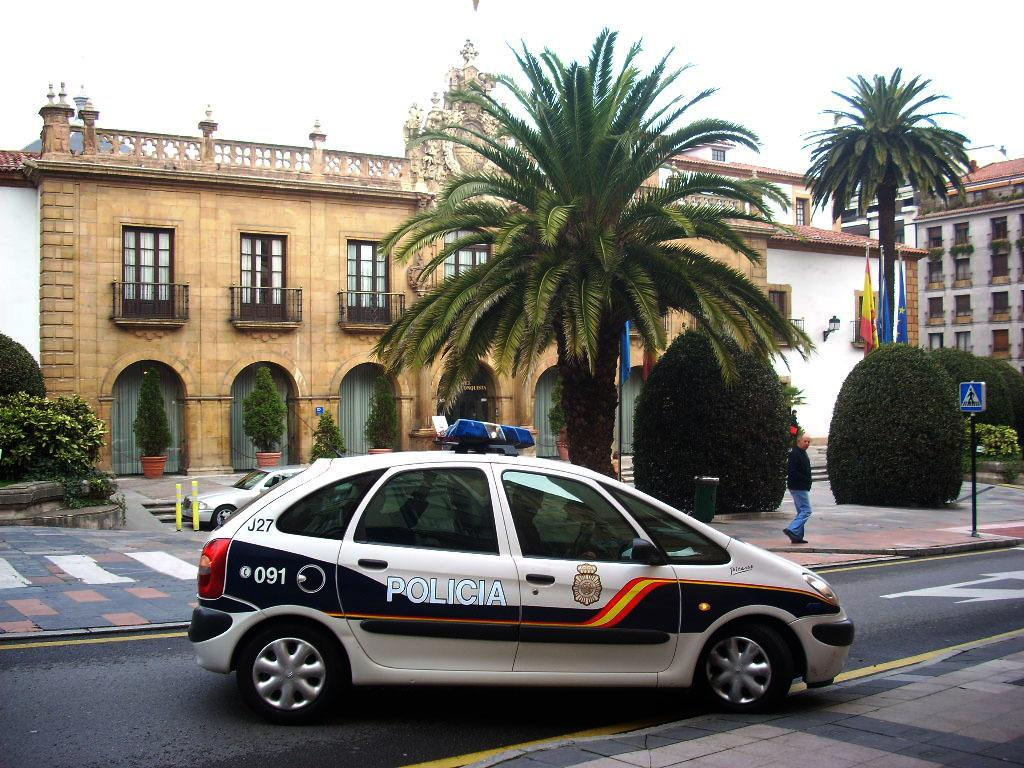What is the main subject of the image? There is a car on the road in the image. What can be seen in the background of the image? The sky is visible in the background of the image. What type of vegetation is present in the image? There are trees in the image. What type of structure is visible in the image? There is a building with windows in the image. What else is present in the image? There are flags, house plants, and a man walking on a footpath in the image. Can you tell me how many kittens are sleeping on the car in the image? There are no kittens present in the image, and therefore no such activity can be observed. What type of hen can be seen walking on the footpath in the image? There is no hen present in the image; it features a man walking on the footpath. 